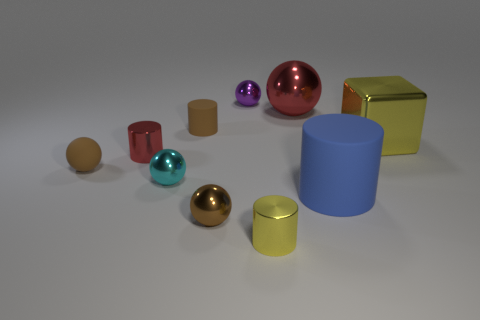Subtract all purple balls. How many balls are left? 4 Subtract all large red balls. How many balls are left? 4 Subtract all yellow cylinders. Subtract all red balls. How many cylinders are left? 3 Subtract all cylinders. How many objects are left? 6 Subtract all small yellow shiny cylinders. Subtract all purple metal balls. How many objects are left? 8 Add 2 tiny purple objects. How many tiny purple objects are left? 3 Add 6 blue matte cylinders. How many blue matte cylinders exist? 7 Subtract 0 cyan cylinders. How many objects are left? 10 